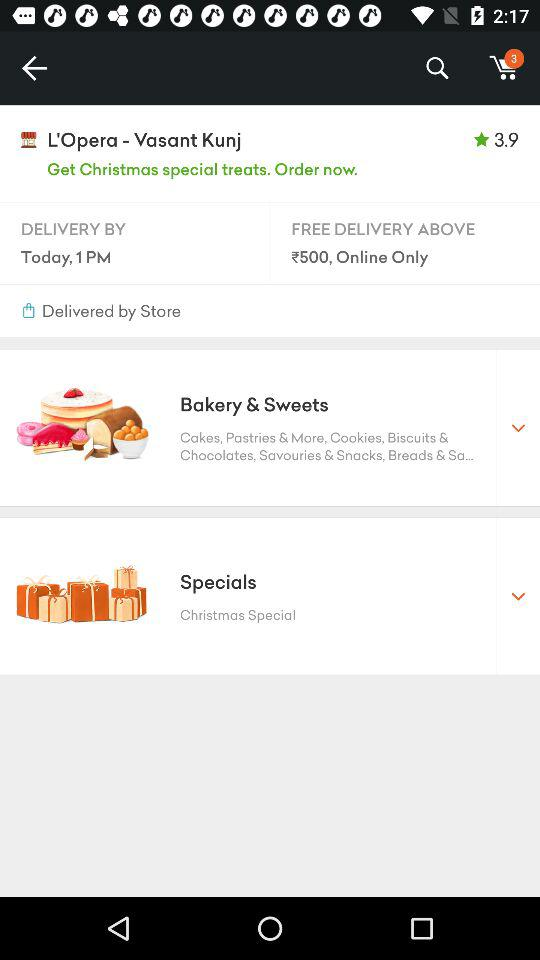How many items are displayed in the shopping cart? There are 3 items displayed in the shopping cart. 